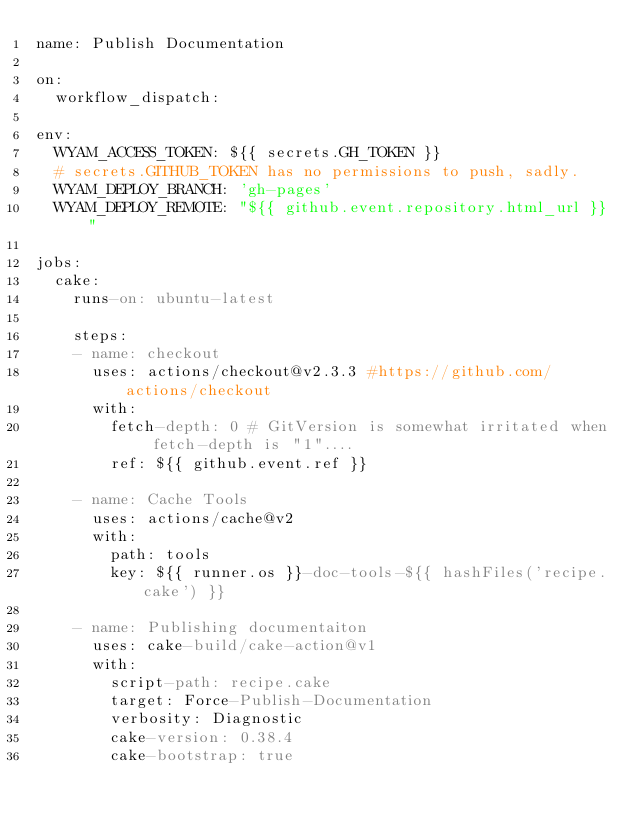Convert code to text. <code><loc_0><loc_0><loc_500><loc_500><_YAML_>name: Publish Documentation

on:
  workflow_dispatch:

env:
  WYAM_ACCESS_TOKEN: ${{ secrets.GH_TOKEN }}
  # secrets.GITHUB_TOKEN has no permissions to push, sadly.
  WYAM_DEPLOY_BRANCH: 'gh-pages'
  WYAM_DEPLOY_REMOTE: "${{ github.event.repository.html_url }}"

jobs:
  cake:
    runs-on: ubuntu-latest

    steps:
    - name: checkout
      uses: actions/checkout@v2.3.3 #https://github.com/actions/checkout
      with:
        fetch-depth: 0 # GitVersion is somewhat irritated when fetch-depth is "1"....
        ref: ${{ github.event.ref }}
    
    - name: Cache Tools
      uses: actions/cache@v2
      with:
        path: tools
        key: ${{ runner.os }}-doc-tools-${{ hashFiles('recipe.cake') }}

    - name: Publishing documentaiton
      uses: cake-build/cake-action@v1
      with:
        script-path: recipe.cake
        target: Force-Publish-Documentation
        verbosity: Diagnostic
        cake-version: 0.38.4
        cake-bootstrap: true
</code> 